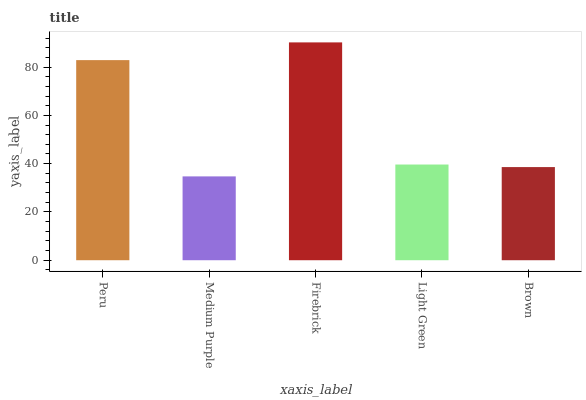Is Firebrick the minimum?
Answer yes or no. No. Is Medium Purple the maximum?
Answer yes or no. No. Is Firebrick greater than Medium Purple?
Answer yes or no. Yes. Is Medium Purple less than Firebrick?
Answer yes or no. Yes. Is Medium Purple greater than Firebrick?
Answer yes or no. No. Is Firebrick less than Medium Purple?
Answer yes or no. No. Is Light Green the high median?
Answer yes or no. Yes. Is Light Green the low median?
Answer yes or no. Yes. Is Brown the high median?
Answer yes or no. No. Is Brown the low median?
Answer yes or no. No. 